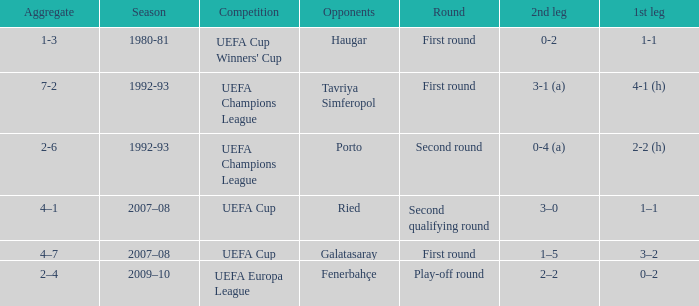What is the total number of 2nd leg where aggregate is 7-2 1.0. 